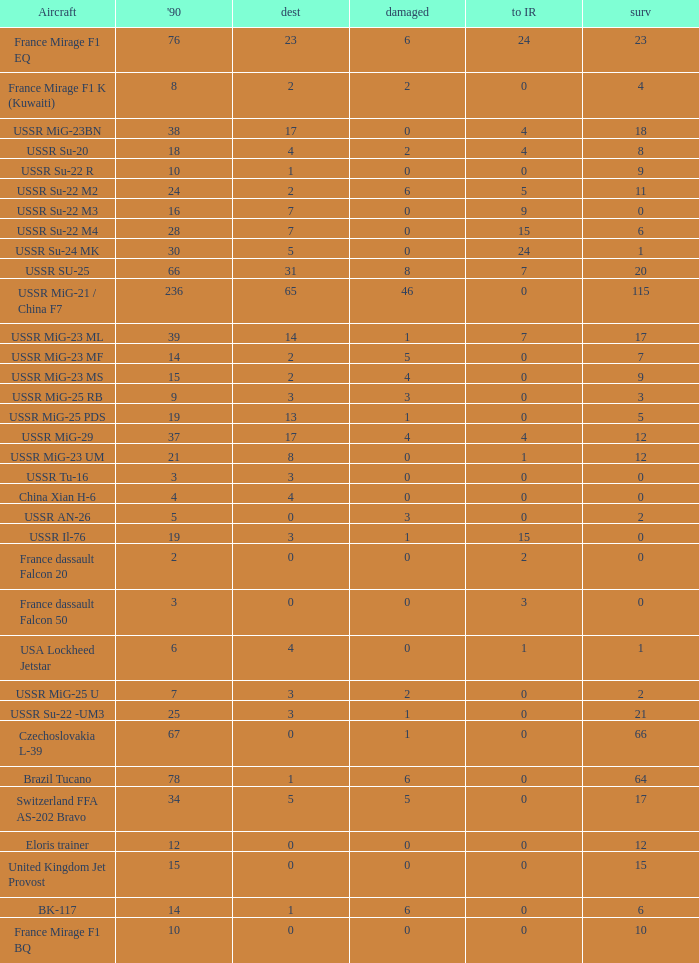If 4 went to iran and the amount that survived was less than 12.0 how many were there in 1990? 1.0. 